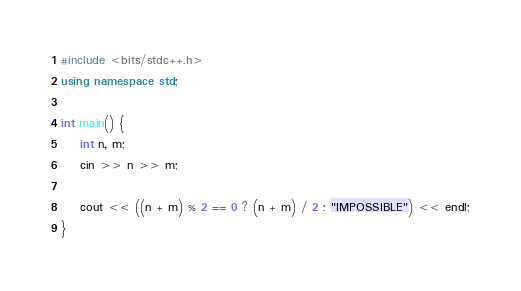<code> <loc_0><loc_0><loc_500><loc_500><_C++_>#include <bits/stdc++.h>
using namespace std;

int main() {
    int n, m;
    cin >> n >> m;

    cout << ((n + m) % 2 == 0 ? (n + m) / 2 : "IMPOSSIBLE") << endl;
}</code> 